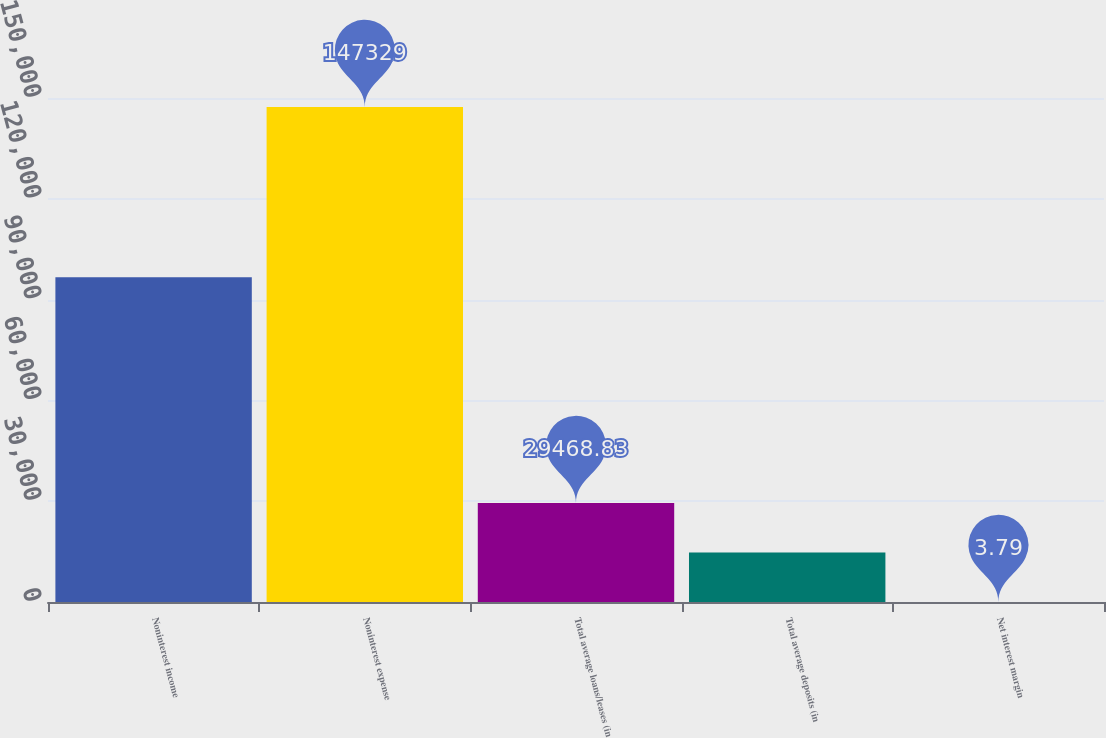<chart> <loc_0><loc_0><loc_500><loc_500><bar_chart><fcel>Noninterest income<fcel>Noninterest expense<fcel>Total average loans/leases (in<fcel>Total average deposits (in<fcel>Net interest margin<nl><fcel>96676<fcel>147329<fcel>29468.8<fcel>14736.3<fcel>3.79<nl></chart> 